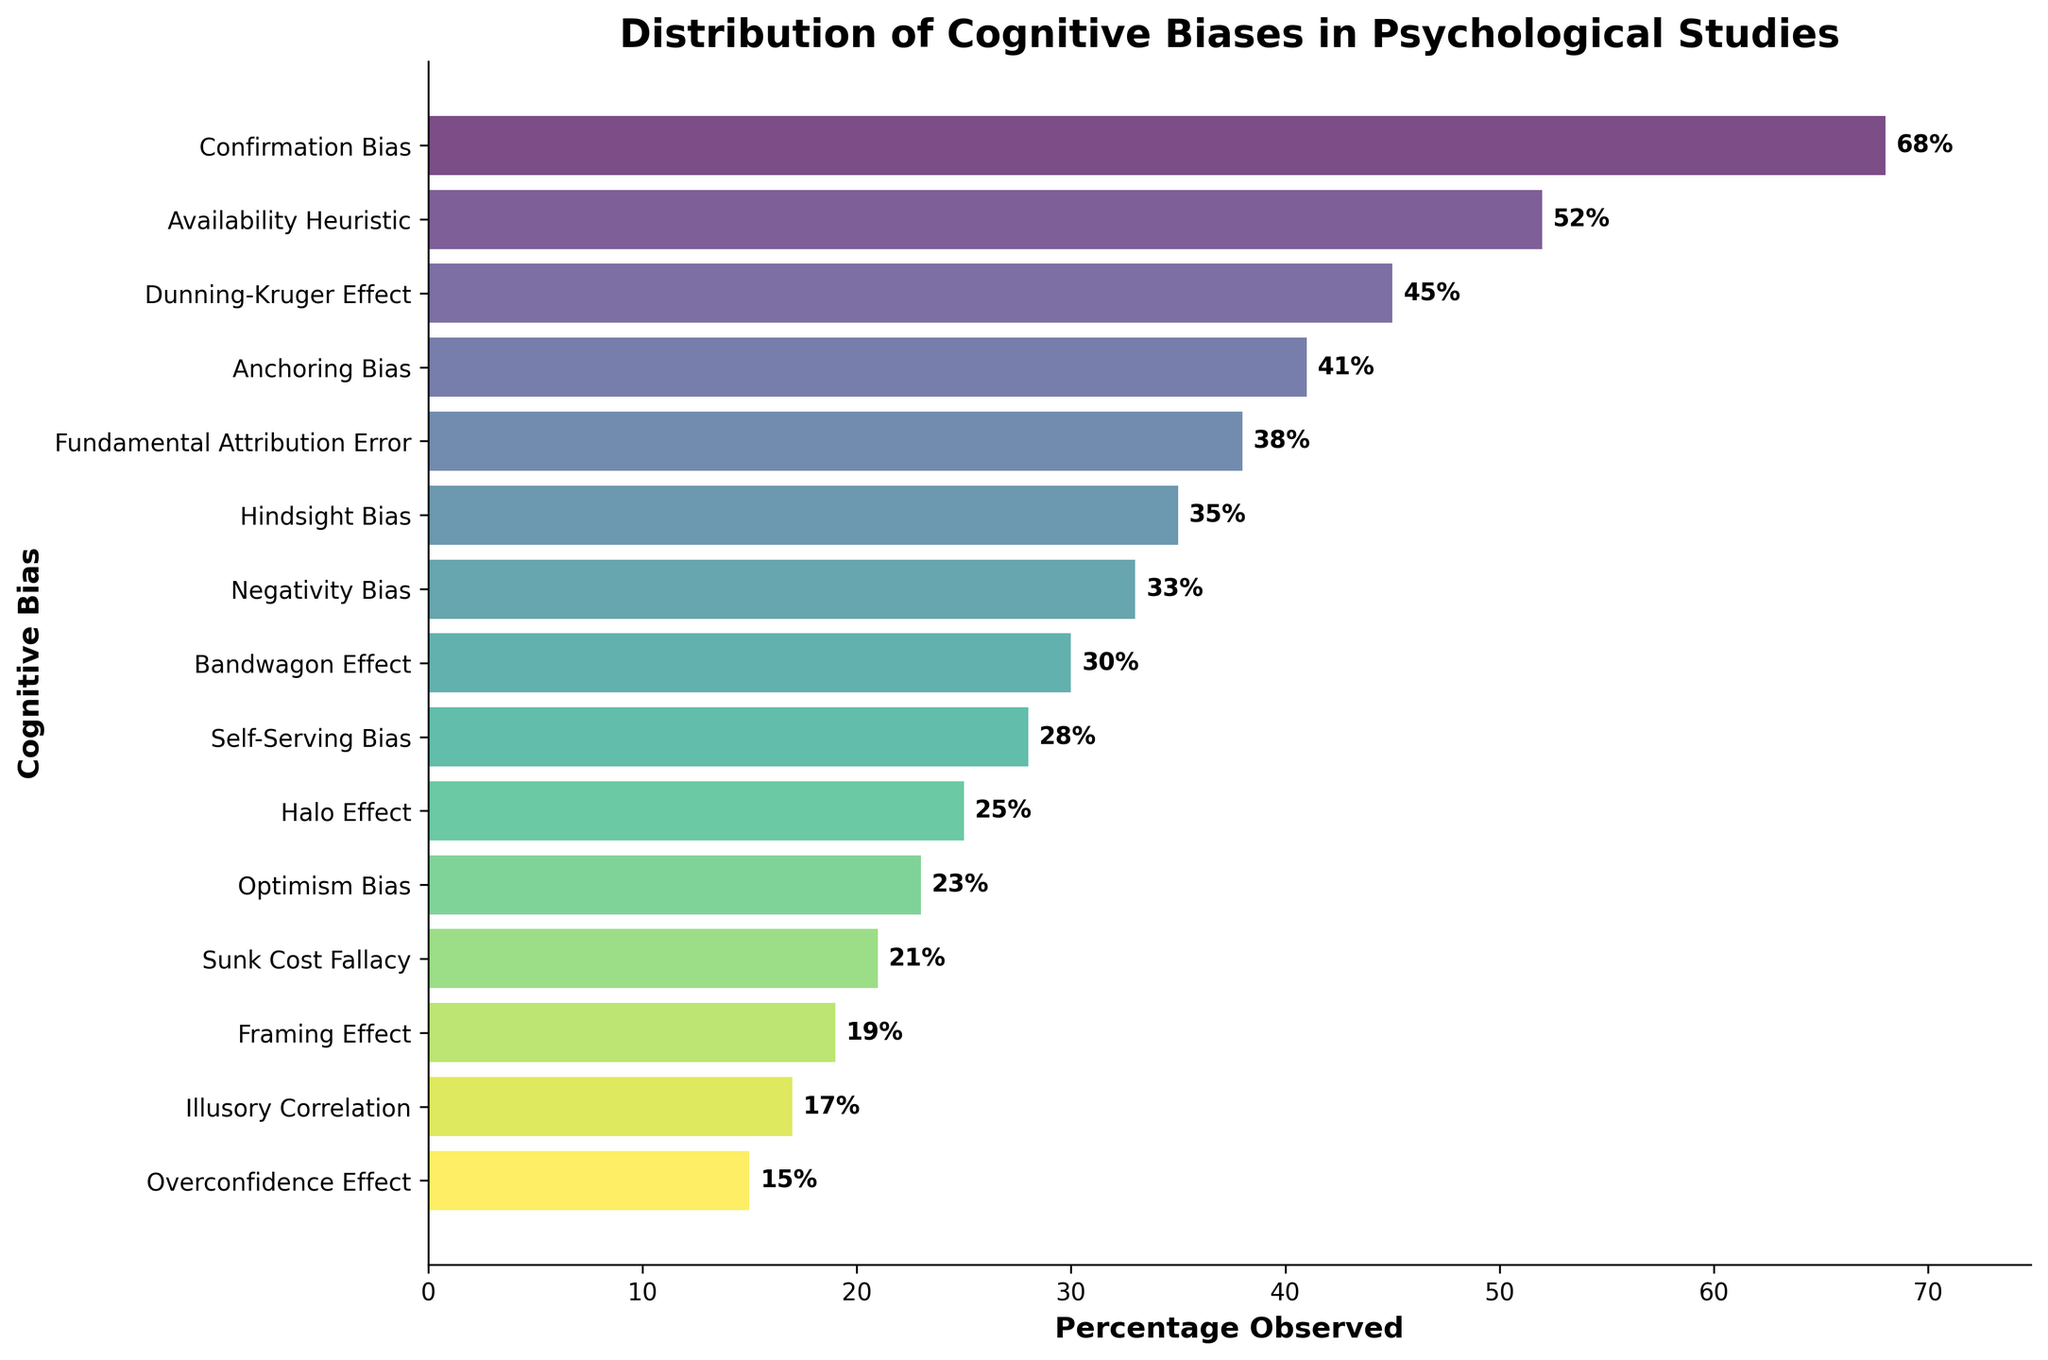What cognitive bias has the highest percentage observed? The figure shows that out of all the cognitive biases listed, "Confirmation Bias" has the highest percentage observed at 68%.
Answer: Confirmation Bias Which cognitive bias has the lowest percentage observed? According to the figure, the cognitive bias with the lowest percentage observed is the "Overconfidence Effect" at 15%.
Answer: Overconfidence Effect How much higher is the percentage observed for Confirmation Bias compared to Anchoring Bias? The figure shows 68% for Confirmation Bias and 41% for Anchoring Bias. The difference is 68% - 41% = 27%.
Answer: 27% Are there more biases with a percentage above 35% or below 35%? Observing the figure, there are 6 biases above 35% (Confirmation Bias, Availability Heuristic, Dunning-Kruger Effect, Anchoring Bias, Fundamental Attribution Error, Hindsight Bias) and 9 biases below 35%. Therefore, there are more biases below 35%.
Answer: Below 35% What is the average percentage observed of the top three biases? The top three biases are Confirmation Bias (68%), Availability Heuristic (52%), and Dunning-Kruger Effect (45%). The average is (68 + 52 + 45) / 3 = 165 / 3 = 55%.
Answer: 55% Which two biases have the closest observed percentages? By examining the figure, the Fundamental Attribution Error (38%) and Hindsight Bias (35%) have the closest observed percentages with a difference of only 3%.
Answer: Fundamental Attribution Error and Hindsight Bias What is the sum of percentages observed for Halo Effect and Bandwagon Effect? The figure shows Halo Effect at 25% and Bandwagon Effect at 30%, so the sum is 25% + 30% = 55%.
Answer: 55% Is the percentage observed for Negativity Bias higher or lower than the percentage observed for Framing Effect, and by how much? Negativity Bias is at 33% and Framing Effect is at 19%. Therefore, the percentage for Negativity Bias is higher by 33% - 19% = 14%.
Answer: Higher by 14% What are the observed percentages for biases that fall between 20% and 30%? From the figure, the biases that fall within this range are Self-Serving Bias (28%), Halo Effect (25%), and Optimism Bias (23%), and Sunk Cost Fallacy (21%).
Answer: 28%, 25%, 23%, and 21% Which bias's bar appears to be the most visually prominent due to its higher percentage observed? The Confirmation Bias's bar is the most visually prominent because its length corresponds to the highest percentage observed at 68%.
Answer: Confirmation Bias 